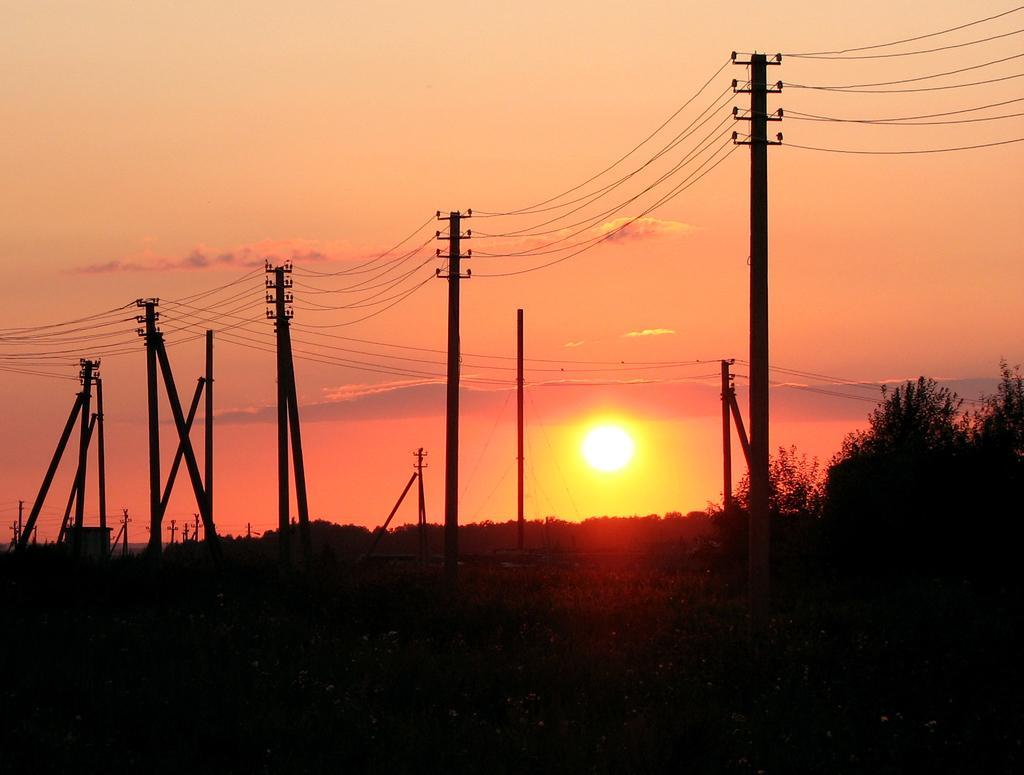How would you summarize this image in a sentence or two? In the image we can see there are electric poles standing on the ground and behind there are lot of trees and there is a sun in the sky. 